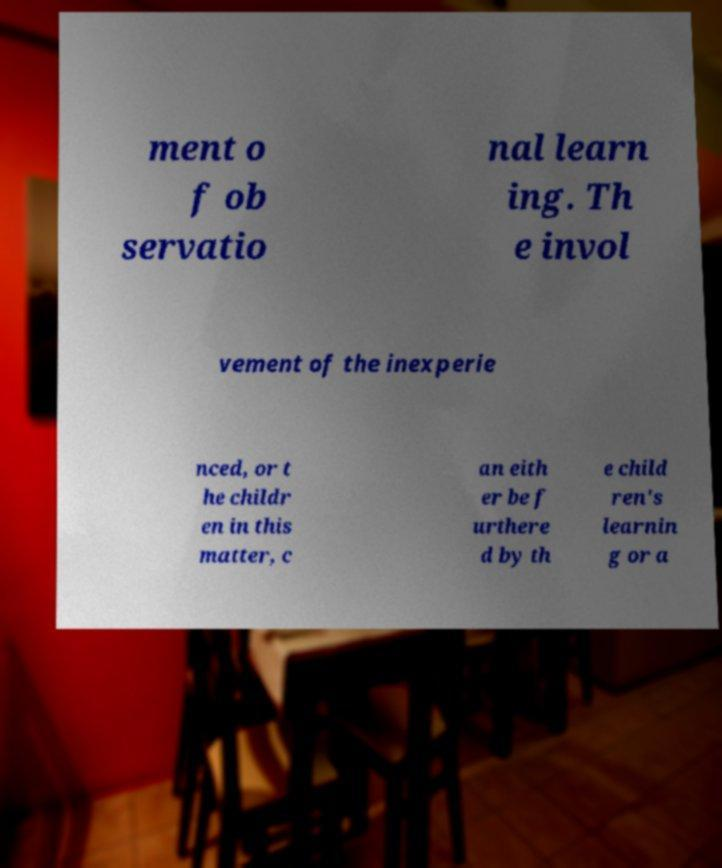For documentation purposes, I need the text within this image transcribed. Could you provide that? ment o f ob servatio nal learn ing. Th e invol vement of the inexperie nced, or t he childr en in this matter, c an eith er be f urthere d by th e child ren's learnin g or a 